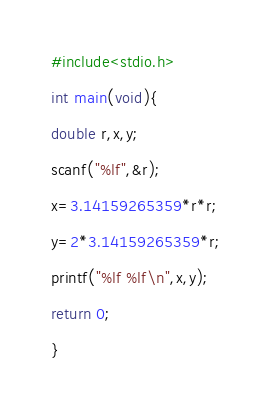<code> <loc_0><loc_0><loc_500><loc_500><_C_>#include<stdio.h>
 
int main(void){
 
double r,x,y;
 
scanf("%lf",&r);
 
x=3.14159265359*r*r;
 
y=2*3.14159265359*r;
 
printf("%lf %lf\n",x,y);
 
return 0;
 
}</code> 